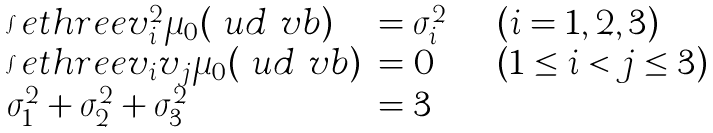<formula> <loc_0><loc_0><loc_500><loc_500>\begin{array} { l l l l } & \int e t h r e e v _ { i } ^ { 2 } \mu _ { 0 } ( \ u d \ v b ) & = \sigma _ { i } ^ { 2 } & \quad ( i = 1 , 2 , 3 ) \\ & \int e t h r e e v _ { i } v _ { j } \mu _ { 0 } ( \ u d \ v b ) & = 0 & \quad ( 1 \leq i < j \leq 3 ) \\ & \sigma _ { 1 } ^ { 2 } + \sigma _ { 2 } ^ { 2 } + \sigma _ { 3 } ^ { 2 } & = 3 \end{array}</formula> 